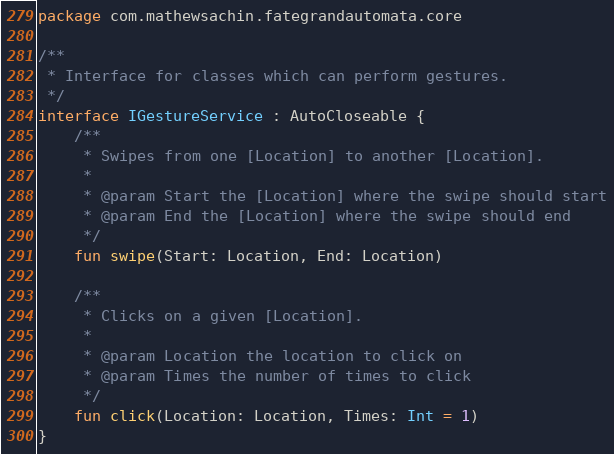Convert code to text. <code><loc_0><loc_0><loc_500><loc_500><_Kotlin_>package com.mathewsachin.fategrandautomata.core

/**
 * Interface for classes which can perform gestures.
 */
interface IGestureService : AutoCloseable {
    /**
     * Swipes from one [Location] to another [Location].
     *
     * @param Start the [Location] where the swipe should start
     * @param End the [Location] where the swipe should end
     */
    fun swipe(Start: Location, End: Location)

    /**
     * Clicks on a given [Location].
     *
     * @param Location the location to click on
     * @param Times the number of times to click
     */
    fun click(Location: Location, Times: Int = 1)
}</code> 